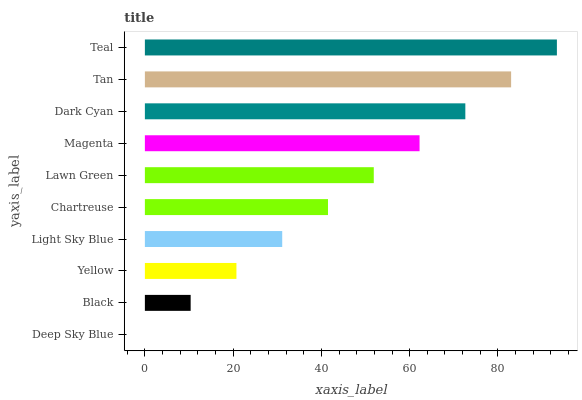Is Deep Sky Blue the minimum?
Answer yes or no. Yes. Is Teal the maximum?
Answer yes or no. Yes. Is Black the minimum?
Answer yes or no. No. Is Black the maximum?
Answer yes or no. No. Is Black greater than Deep Sky Blue?
Answer yes or no. Yes. Is Deep Sky Blue less than Black?
Answer yes or no. Yes. Is Deep Sky Blue greater than Black?
Answer yes or no. No. Is Black less than Deep Sky Blue?
Answer yes or no. No. Is Lawn Green the high median?
Answer yes or no. Yes. Is Chartreuse the low median?
Answer yes or no. Yes. Is Tan the high median?
Answer yes or no. No. Is Light Sky Blue the low median?
Answer yes or no. No. 